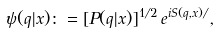Convert formula to latex. <formula><loc_0><loc_0><loc_500><loc_500>\psi ( q | x ) \colon = [ P ( q | x ) ] ^ { 1 / 2 } \, e ^ { i S ( q , x ) / } ,</formula> 